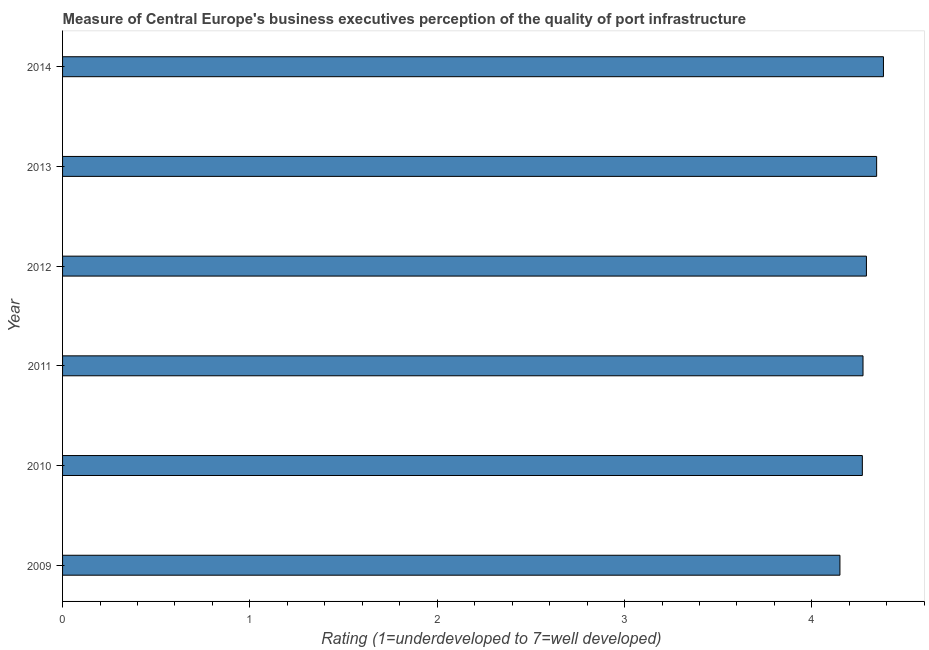Does the graph contain grids?
Your answer should be very brief. No. What is the title of the graph?
Ensure brevity in your answer.  Measure of Central Europe's business executives perception of the quality of port infrastructure. What is the label or title of the X-axis?
Provide a short and direct response. Rating (1=underdeveloped to 7=well developed) . What is the label or title of the Y-axis?
Ensure brevity in your answer.  Year. What is the rating measuring quality of port infrastructure in 2011?
Give a very brief answer. 4.27. Across all years, what is the maximum rating measuring quality of port infrastructure?
Ensure brevity in your answer.  4.38. Across all years, what is the minimum rating measuring quality of port infrastructure?
Offer a very short reply. 4.15. In which year was the rating measuring quality of port infrastructure maximum?
Offer a terse response. 2014. What is the sum of the rating measuring quality of port infrastructure?
Provide a succinct answer. 25.71. What is the difference between the rating measuring quality of port infrastructure in 2011 and 2014?
Make the answer very short. -0.11. What is the average rating measuring quality of port infrastructure per year?
Offer a terse response. 4.29. What is the median rating measuring quality of port infrastructure?
Your answer should be compact. 4.28. Do a majority of the years between 2014 and 2011 (inclusive) have rating measuring quality of port infrastructure greater than 1.4 ?
Offer a very short reply. Yes. What is the difference between the highest and the second highest rating measuring quality of port infrastructure?
Offer a very short reply. 0.04. Is the sum of the rating measuring quality of port infrastructure in 2009 and 2012 greater than the maximum rating measuring quality of port infrastructure across all years?
Keep it short and to the point. Yes. What is the difference between the highest and the lowest rating measuring quality of port infrastructure?
Keep it short and to the point. 0.23. In how many years, is the rating measuring quality of port infrastructure greater than the average rating measuring quality of port infrastructure taken over all years?
Offer a terse response. 3. How many bars are there?
Your answer should be compact. 6. Are all the bars in the graph horizontal?
Provide a short and direct response. Yes. Are the values on the major ticks of X-axis written in scientific E-notation?
Provide a short and direct response. No. What is the Rating (1=underdeveloped to 7=well developed)  of 2009?
Keep it short and to the point. 4.15. What is the Rating (1=underdeveloped to 7=well developed)  in 2010?
Offer a terse response. 4.27. What is the Rating (1=underdeveloped to 7=well developed)  of 2011?
Keep it short and to the point. 4.27. What is the Rating (1=underdeveloped to 7=well developed)  in 2012?
Your response must be concise. 4.29. What is the Rating (1=underdeveloped to 7=well developed)  in 2013?
Your response must be concise. 4.35. What is the Rating (1=underdeveloped to 7=well developed)  in 2014?
Your answer should be compact. 4.38. What is the difference between the Rating (1=underdeveloped to 7=well developed)  in 2009 and 2010?
Offer a terse response. -0.12. What is the difference between the Rating (1=underdeveloped to 7=well developed)  in 2009 and 2011?
Your answer should be very brief. -0.12. What is the difference between the Rating (1=underdeveloped to 7=well developed)  in 2009 and 2012?
Ensure brevity in your answer.  -0.14. What is the difference between the Rating (1=underdeveloped to 7=well developed)  in 2009 and 2013?
Provide a succinct answer. -0.2. What is the difference between the Rating (1=underdeveloped to 7=well developed)  in 2009 and 2014?
Make the answer very short. -0.23. What is the difference between the Rating (1=underdeveloped to 7=well developed)  in 2010 and 2011?
Ensure brevity in your answer.  -0. What is the difference between the Rating (1=underdeveloped to 7=well developed)  in 2010 and 2012?
Offer a terse response. -0.02. What is the difference between the Rating (1=underdeveloped to 7=well developed)  in 2010 and 2013?
Make the answer very short. -0.08. What is the difference between the Rating (1=underdeveloped to 7=well developed)  in 2010 and 2014?
Your response must be concise. -0.11. What is the difference between the Rating (1=underdeveloped to 7=well developed)  in 2011 and 2012?
Ensure brevity in your answer.  -0.02. What is the difference between the Rating (1=underdeveloped to 7=well developed)  in 2011 and 2013?
Offer a terse response. -0.07. What is the difference between the Rating (1=underdeveloped to 7=well developed)  in 2011 and 2014?
Your answer should be compact. -0.11. What is the difference between the Rating (1=underdeveloped to 7=well developed)  in 2012 and 2013?
Offer a very short reply. -0.05. What is the difference between the Rating (1=underdeveloped to 7=well developed)  in 2012 and 2014?
Ensure brevity in your answer.  -0.09. What is the difference between the Rating (1=underdeveloped to 7=well developed)  in 2013 and 2014?
Your answer should be compact. -0.04. What is the ratio of the Rating (1=underdeveloped to 7=well developed)  in 2009 to that in 2011?
Make the answer very short. 0.97. What is the ratio of the Rating (1=underdeveloped to 7=well developed)  in 2009 to that in 2012?
Make the answer very short. 0.97. What is the ratio of the Rating (1=underdeveloped to 7=well developed)  in 2009 to that in 2013?
Provide a succinct answer. 0.95. What is the ratio of the Rating (1=underdeveloped to 7=well developed)  in 2009 to that in 2014?
Make the answer very short. 0.95. What is the ratio of the Rating (1=underdeveloped to 7=well developed)  in 2010 to that in 2011?
Your answer should be very brief. 1. What is the ratio of the Rating (1=underdeveloped to 7=well developed)  in 2010 to that in 2013?
Ensure brevity in your answer.  0.98. What is the ratio of the Rating (1=underdeveloped to 7=well developed)  in 2010 to that in 2014?
Give a very brief answer. 0.97. What is the ratio of the Rating (1=underdeveloped to 7=well developed)  in 2011 to that in 2012?
Provide a succinct answer. 1. What is the ratio of the Rating (1=underdeveloped to 7=well developed)  in 2011 to that in 2013?
Provide a short and direct response. 0.98. What is the ratio of the Rating (1=underdeveloped to 7=well developed)  in 2011 to that in 2014?
Offer a very short reply. 0.97. What is the ratio of the Rating (1=underdeveloped to 7=well developed)  in 2012 to that in 2013?
Your answer should be compact. 0.99. 